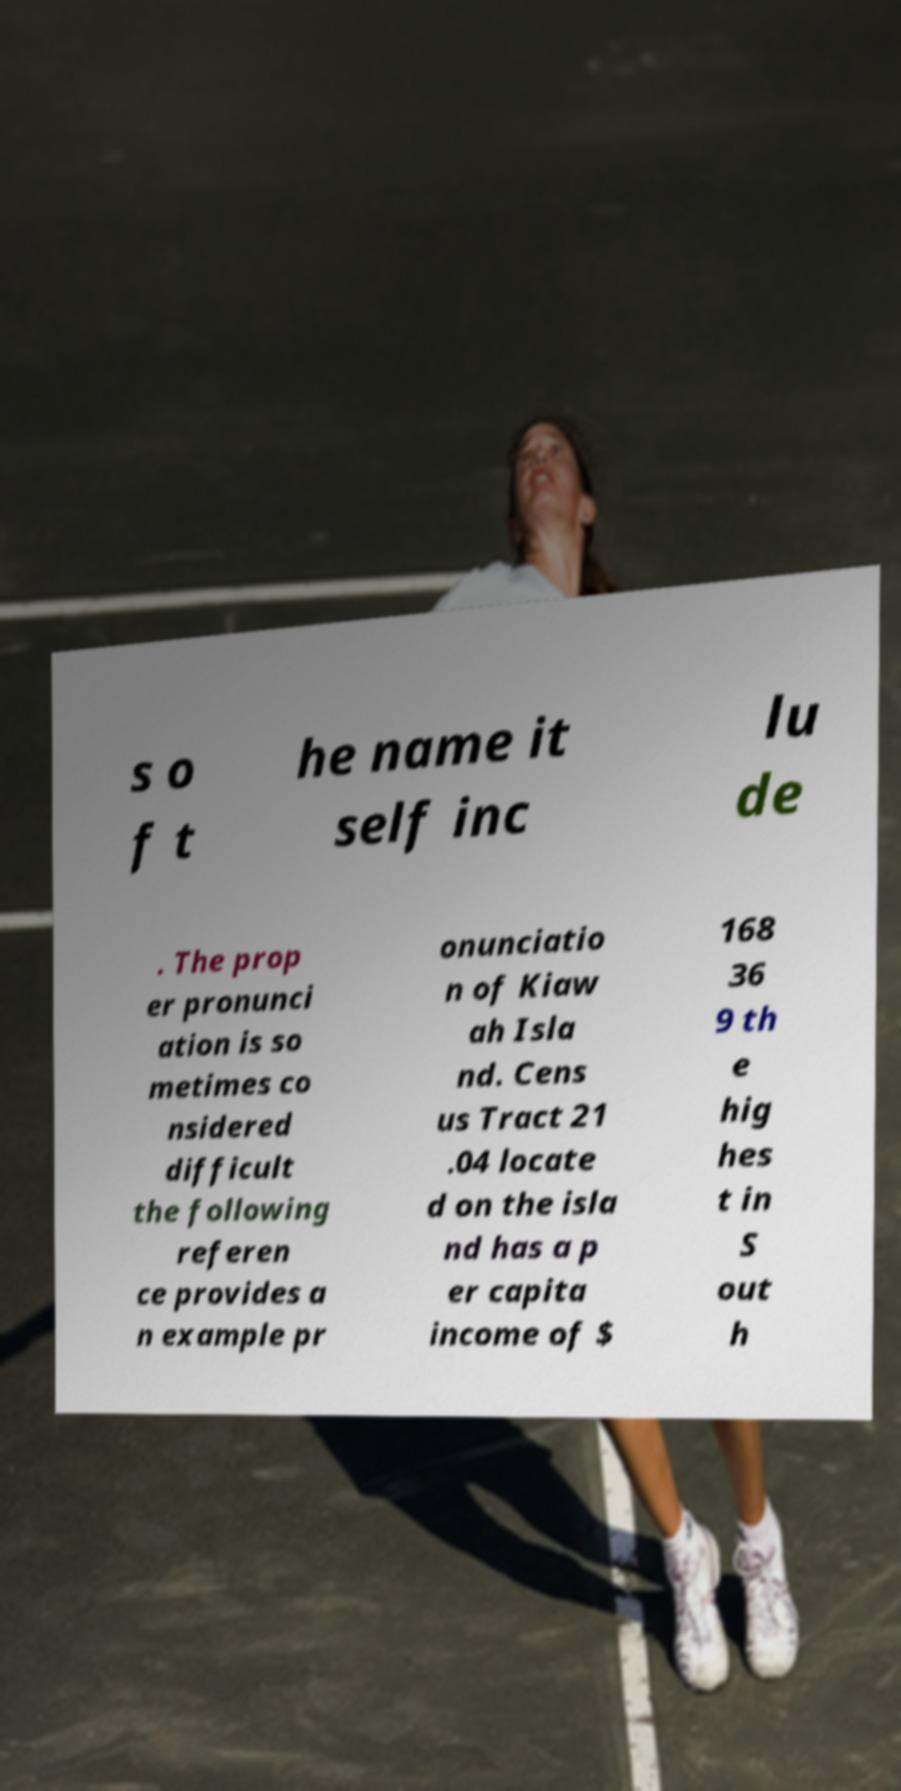I need the written content from this picture converted into text. Can you do that? s o f t he name it self inc lu de . The prop er pronunci ation is so metimes co nsidered difficult the following referen ce provides a n example pr onunciatio n of Kiaw ah Isla nd. Cens us Tract 21 .04 locate d on the isla nd has a p er capita income of $ 168 36 9 th e hig hes t in S out h 